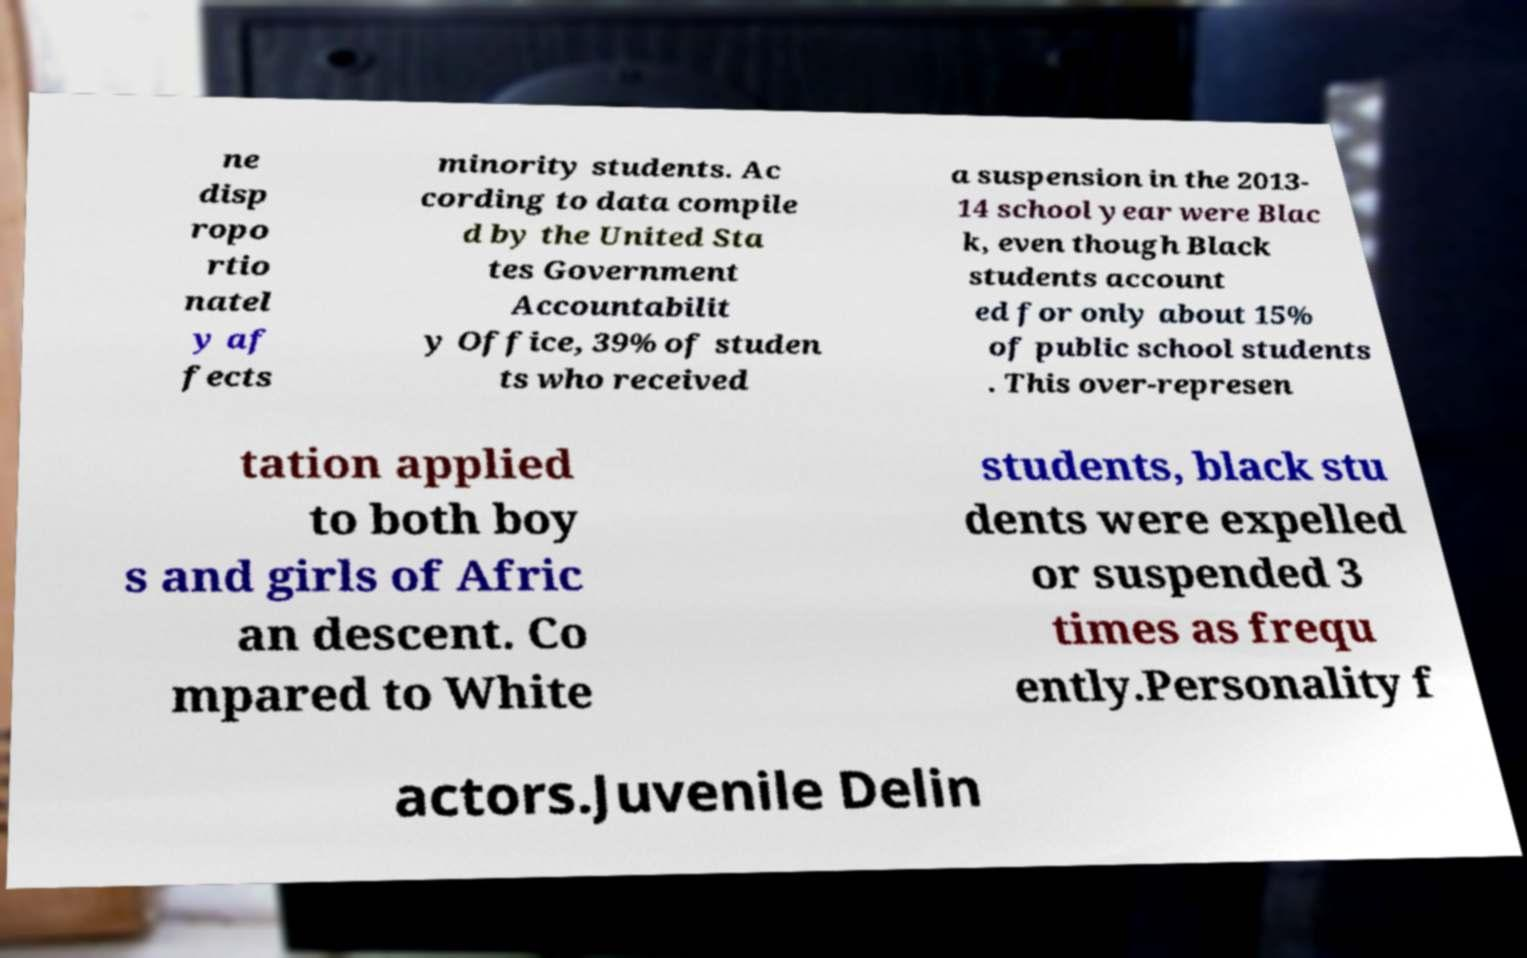Could you extract and type out the text from this image? ne disp ropo rtio natel y af fects minority students. Ac cording to data compile d by the United Sta tes Government Accountabilit y Office, 39% of studen ts who received a suspension in the 2013- 14 school year were Blac k, even though Black students account ed for only about 15% of public school students . This over-represen tation applied to both boy s and girls of Afric an descent. Co mpared to White students, black stu dents were expelled or suspended 3 times as frequ ently.Personality f actors.Juvenile Delin 